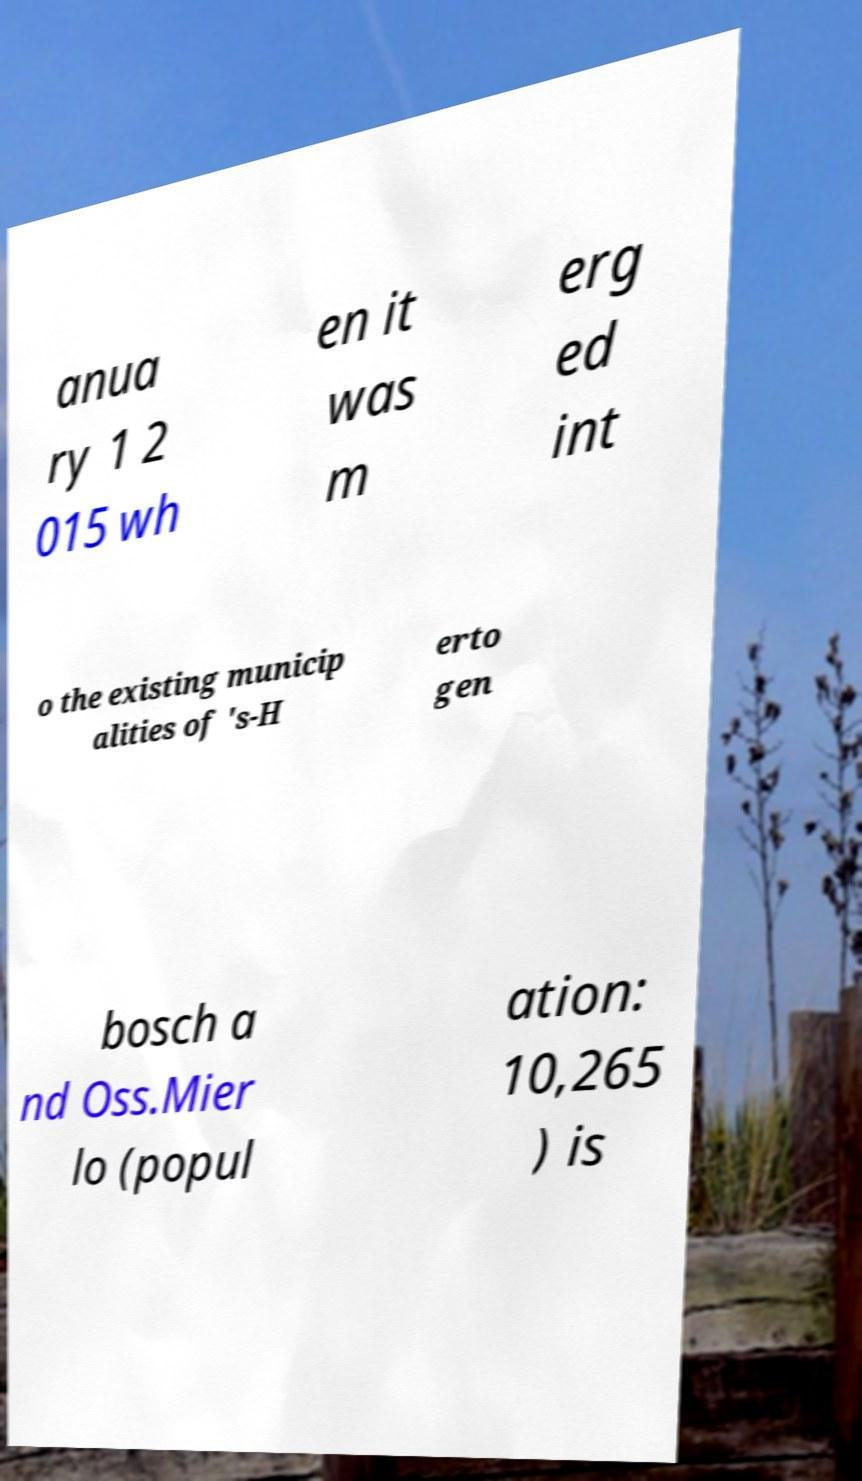Could you extract and type out the text from this image? anua ry 1 2 015 wh en it was m erg ed int o the existing municip alities of 's-H erto gen bosch a nd Oss.Mier lo (popul ation: 10,265 ) is 